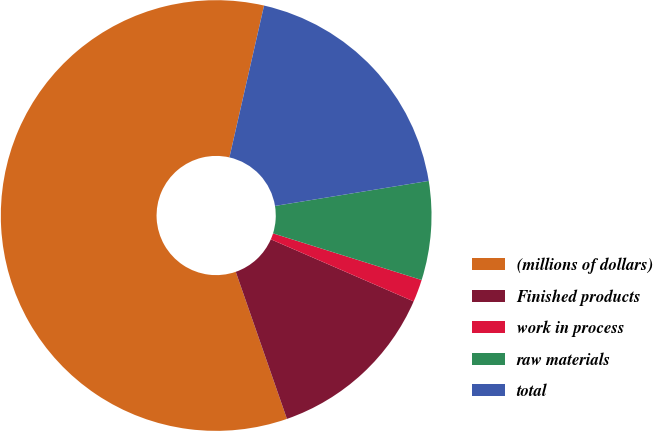Convert chart. <chart><loc_0><loc_0><loc_500><loc_500><pie_chart><fcel>(millions of dollars)<fcel>Finished products<fcel>work in process<fcel>raw materials<fcel>total<nl><fcel>58.9%<fcel>13.14%<fcel>1.69%<fcel>7.41%<fcel>18.86%<nl></chart> 